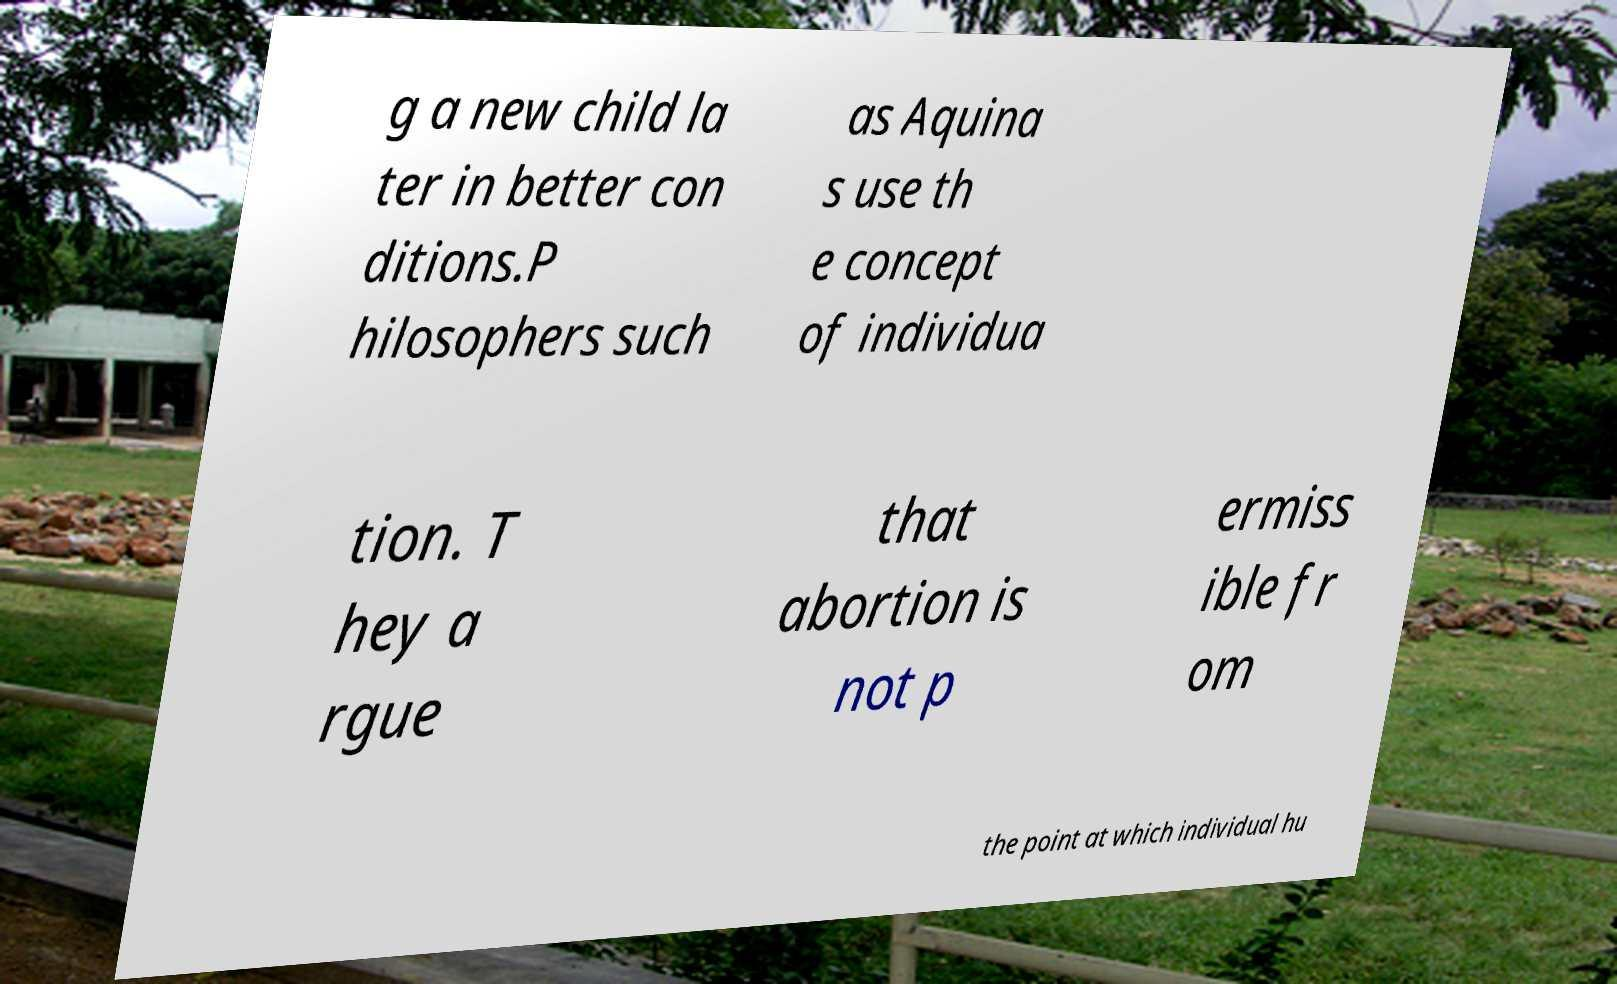What messages or text are displayed in this image? I need them in a readable, typed format. g a new child la ter in better con ditions.P hilosophers such as Aquina s use th e concept of individua tion. T hey a rgue that abortion is not p ermiss ible fr om the point at which individual hu 